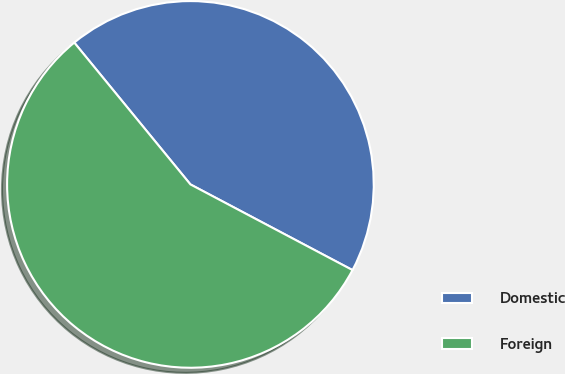<chart> <loc_0><loc_0><loc_500><loc_500><pie_chart><fcel>Domestic<fcel>Foreign<nl><fcel>43.66%<fcel>56.34%<nl></chart> 